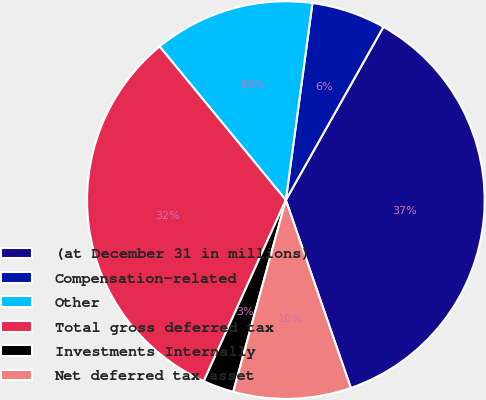Convert chart. <chart><loc_0><loc_0><loc_500><loc_500><pie_chart><fcel>(at December 31 in millions)<fcel>Compensation-related<fcel>Other<fcel>Total gross deferred tax<fcel>Investments Internally<fcel>Net deferred tax asset<nl><fcel>36.54%<fcel>6.03%<fcel>13.09%<fcel>32.28%<fcel>2.51%<fcel>9.56%<nl></chart> 